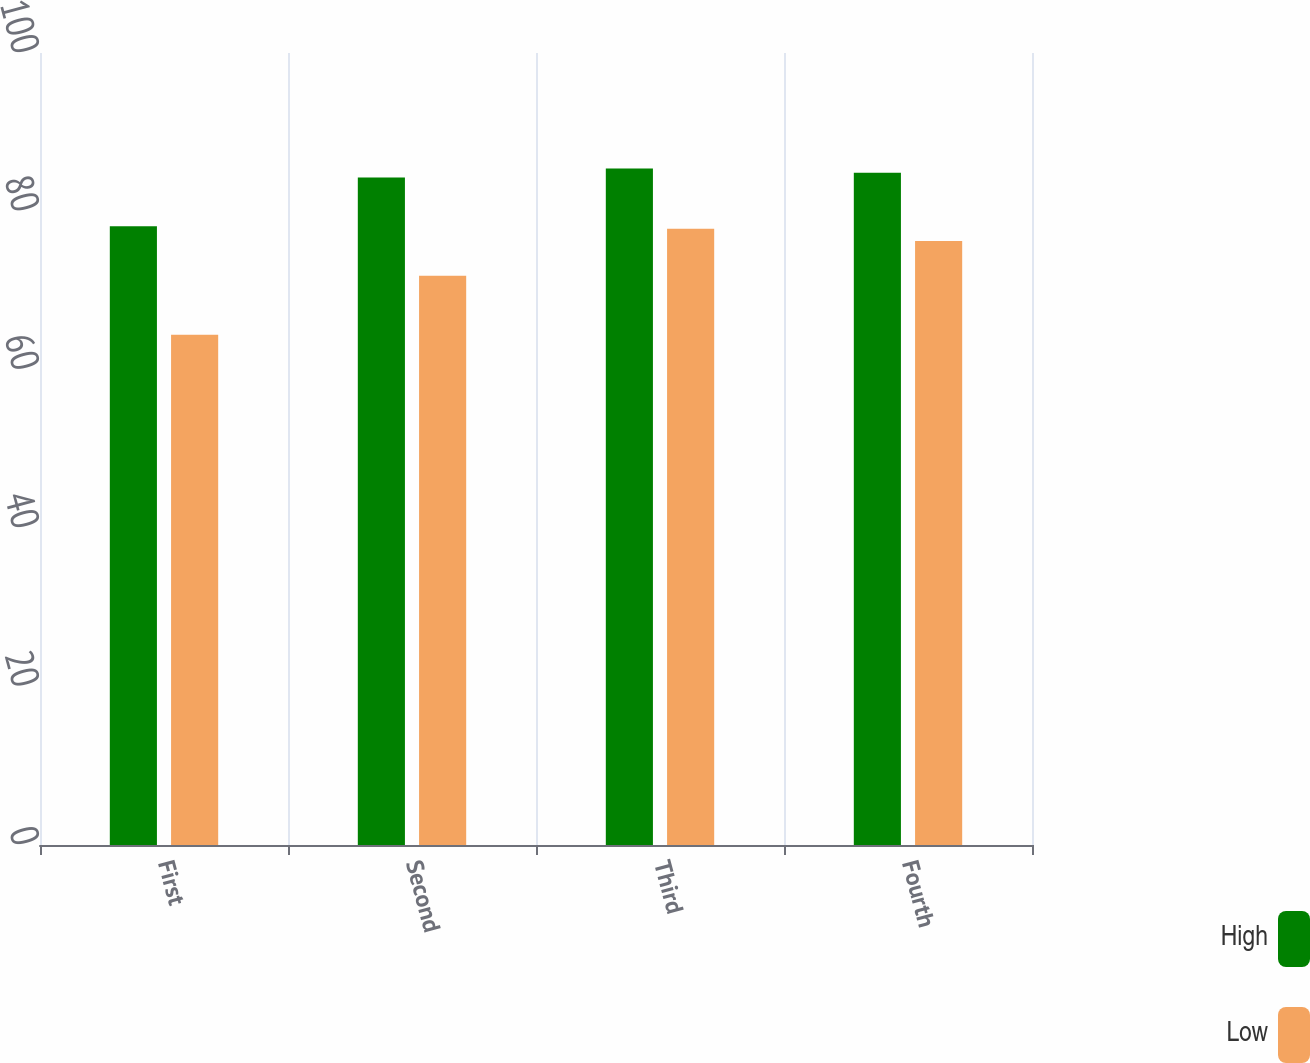Convert chart. <chart><loc_0><loc_0><loc_500><loc_500><stacked_bar_chart><ecel><fcel>First<fcel>Second<fcel>Third<fcel>Fourth<nl><fcel>High<fcel>78.12<fcel>84.27<fcel>85.41<fcel>84.89<nl><fcel>Low<fcel>64.43<fcel>71.87<fcel>77.8<fcel>76.26<nl></chart> 